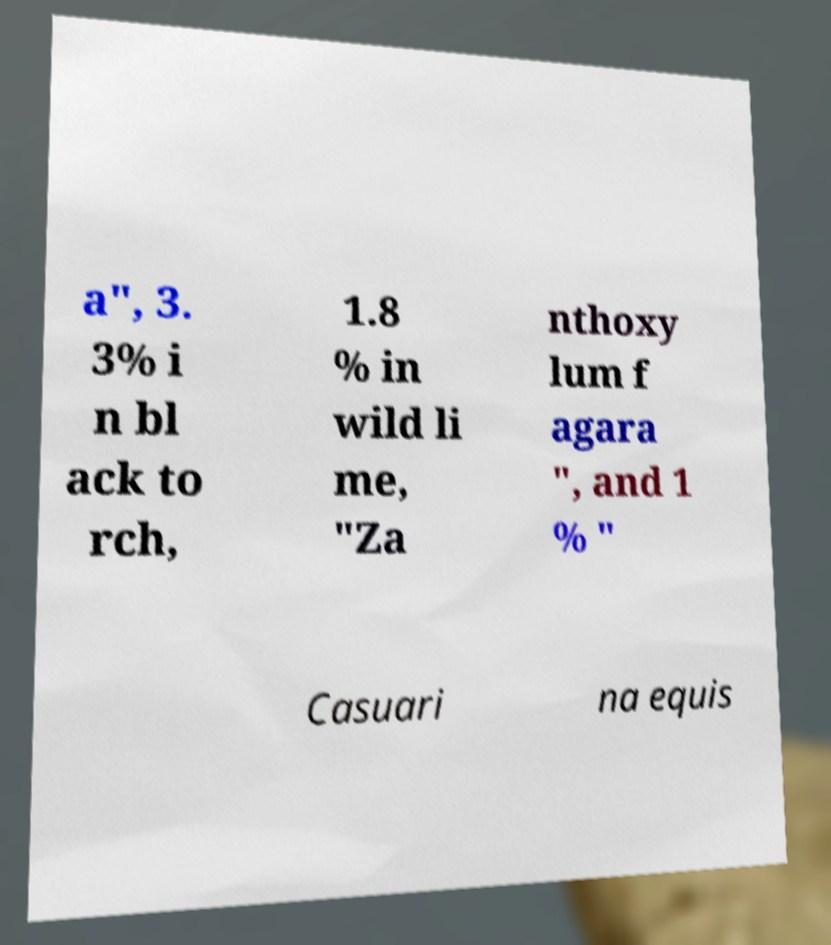Please identify and transcribe the text found in this image. a", 3. 3% i n bl ack to rch, 1.8 % in wild li me, "Za nthoxy lum f agara ", and 1 % " Casuari na equis 